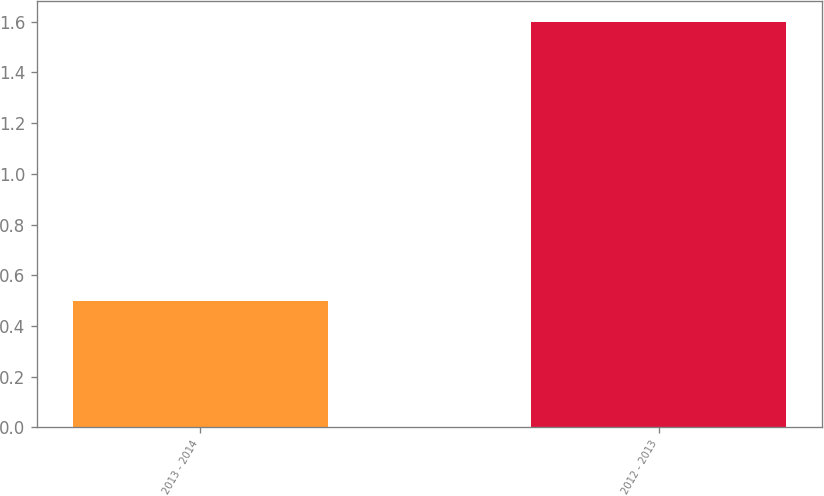Convert chart. <chart><loc_0><loc_0><loc_500><loc_500><bar_chart><fcel>2013 - 2014<fcel>2012 - 2013<nl><fcel>0.5<fcel>1.6<nl></chart> 